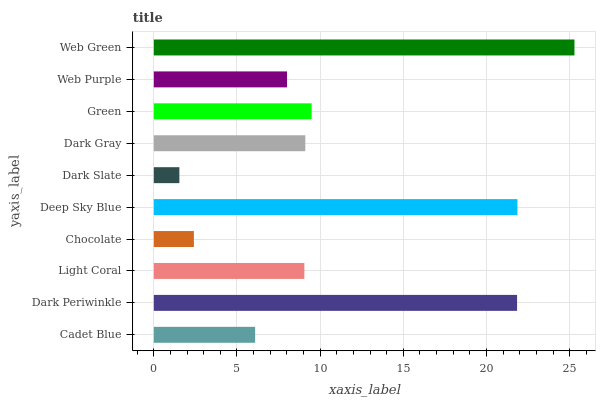Is Dark Slate the minimum?
Answer yes or no. Yes. Is Web Green the maximum?
Answer yes or no. Yes. Is Dark Periwinkle the minimum?
Answer yes or no. No. Is Dark Periwinkle the maximum?
Answer yes or no. No. Is Dark Periwinkle greater than Cadet Blue?
Answer yes or no. Yes. Is Cadet Blue less than Dark Periwinkle?
Answer yes or no. Yes. Is Cadet Blue greater than Dark Periwinkle?
Answer yes or no. No. Is Dark Periwinkle less than Cadet Blue?
Answer yes or no. No. Is Dark Gray the high median?
Answer yes or no. Yes. Is Light Coral the low median?
Answer yes or no. Yes. Is Green the high median?
Answer yes or no. No. Is Web Purple the low median?
Answer yes or no. No. 